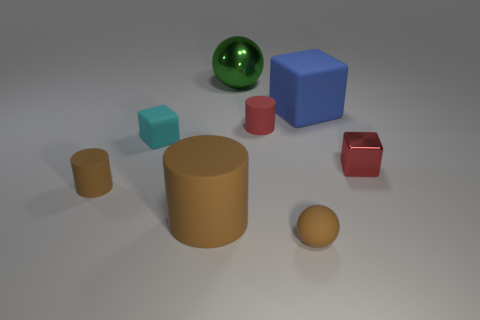Is the number of large cyan matte things less than the number of matte cylinders?
Provide a short and direct response. Yes. Does the tiny rubber cylinder behind the tiny metal block have the same color as the small metallic cube?
Offer a terse response. Yes. There is a large object that is the same material as the large brown cylinder; what color is it?
Your answer should be very brief. Blue. Do the red cube and the green metal sphere have the same size?
Give a very brief answer. No. What is the large green thing made of?
Provide a short and direct response. Metal. What material is the red block that is the same size as the red rubber cylinder?
Your answer should be very brief. Metal. Is there a brown cylinder that has the same size as the cyan object?
Your answer should be very brief. Yes. Is the number of brown cylinders that are to the left of the large brown object the same as the number of tiny cubes that are right of the big metal ball?
Make the answer very short. Yes. Are there more large blue cubes than small cyan cylinders?
Keep it short and to the point. Yes. How many matte things are red cubes or large green cylinders?
Ensure brevity in your answer.  0. 